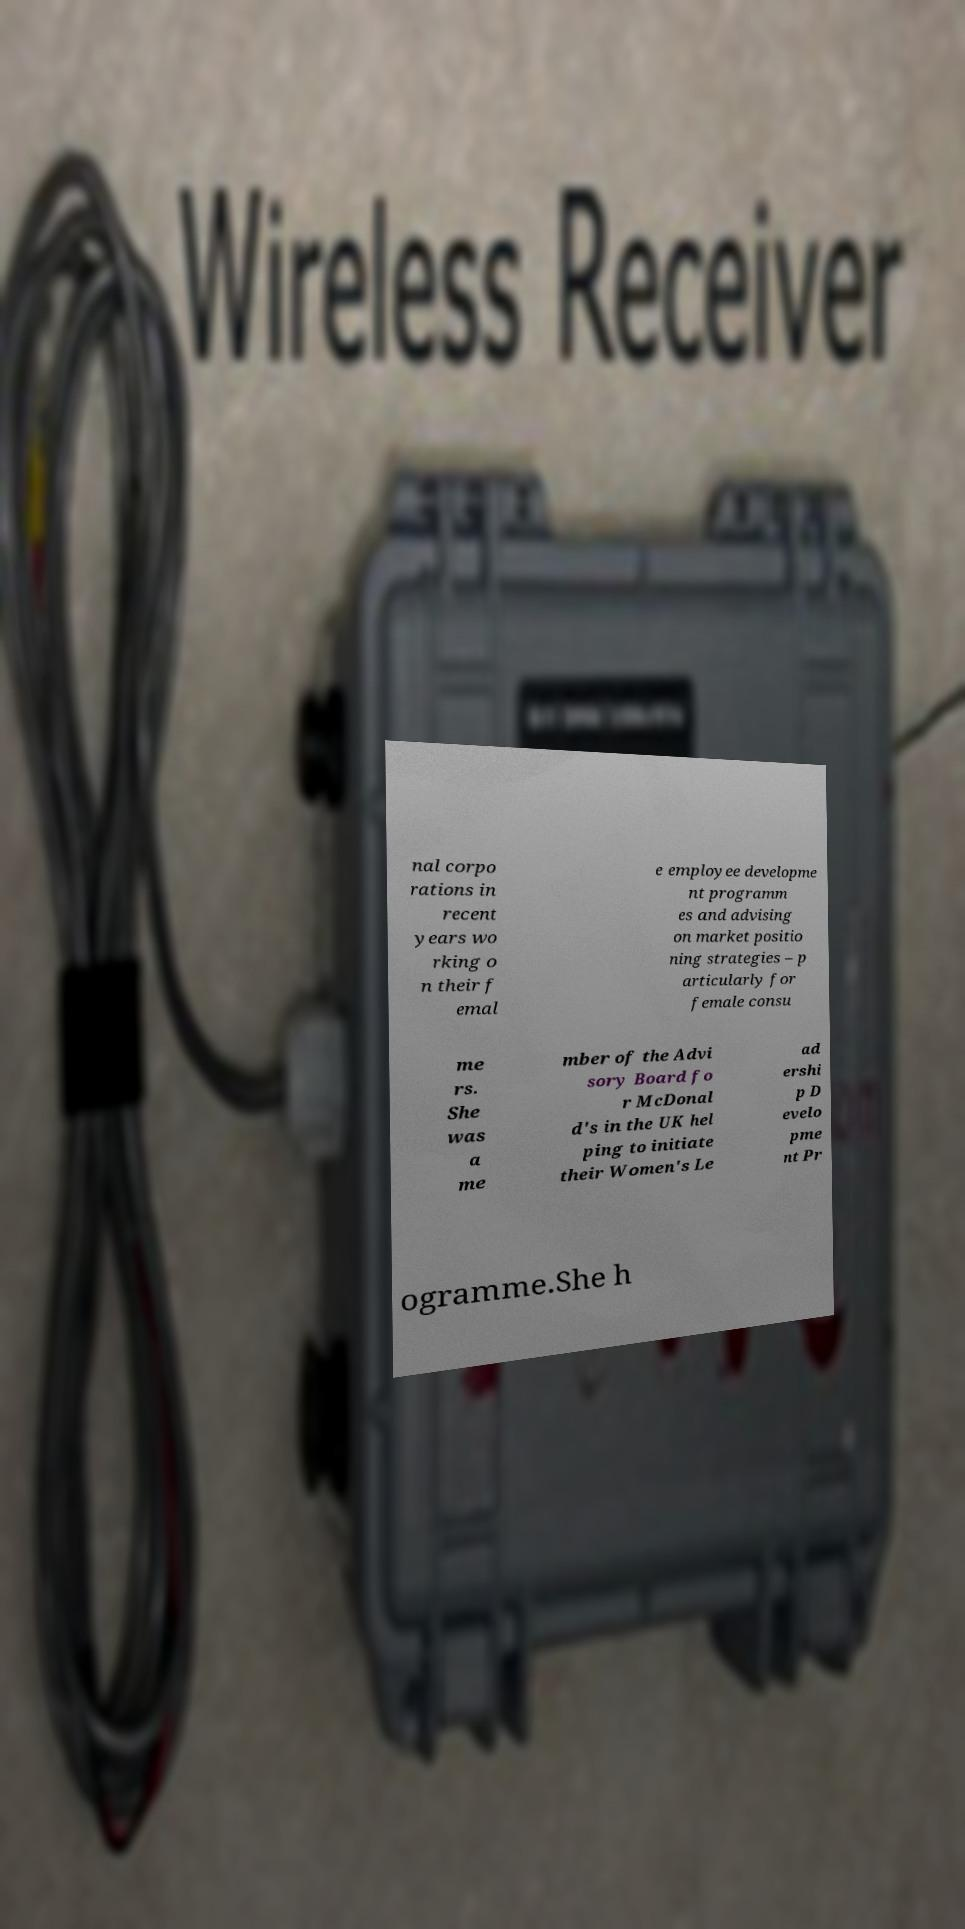What messages or text are displayed in this image? I need them in a readable, typed format. nal corpo rations in recent years wo rking o n their f emal e employee developme nt programm es and advising on market positio ning strategies – p articularly for female consu me rs. She was a me mber of the Advi sory Board fo r McDonal d's in the UK hel ping to initiate their Women's Le ad ershi p D evelo pme nt Pr ogramme.She h 